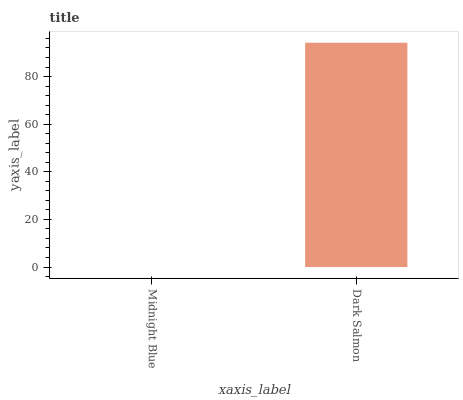Is Midnight Blue the minimum?
Answer yes or no. Yes. Is Dark Salmon the maximum?
Answer yes or no. Yes. Is Dark Salmon the minimum?
Answer yes or no. No. Is Dark Salmon greater than Midnight Blue?
Answer yes or no. Yes. Is Midnight Blue less than Dark Salmon?
Answer yes or no. Yes. Is Midnight Blue greater than Dark Salmon?
Answer yes or no. No. Is Dark Salmon less than Midnight Blue?
Answer yes or no. No. Is Dark Salmon the high median?
Answer yes or no. Yes. Is Midnight Blue the low median?
Answer yes or no. Yes. Is Midnight Blue the high median?
Answer yes or no. No. Is Dark Salmon the low median?
Answer yes or no. No. 